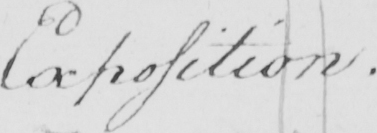Please provide the text content of this handwritten line. Exposition . 